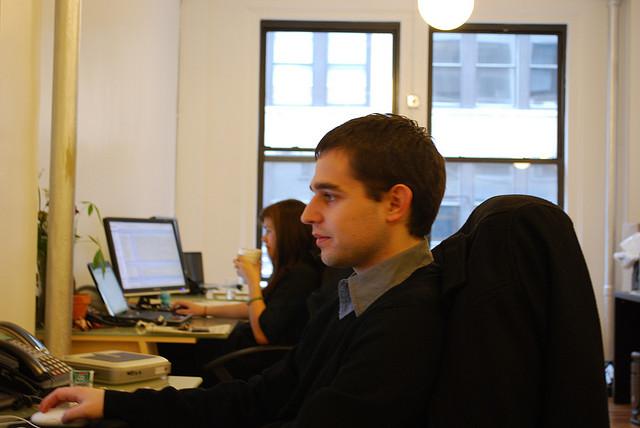What is this kind of work setting?
Keep it brief. Office. Have they been drinking beer?
Short answer required. No. How many windows are there?
Short answer required. 2. How many people are in the photo?
Keep it brief. 2. 